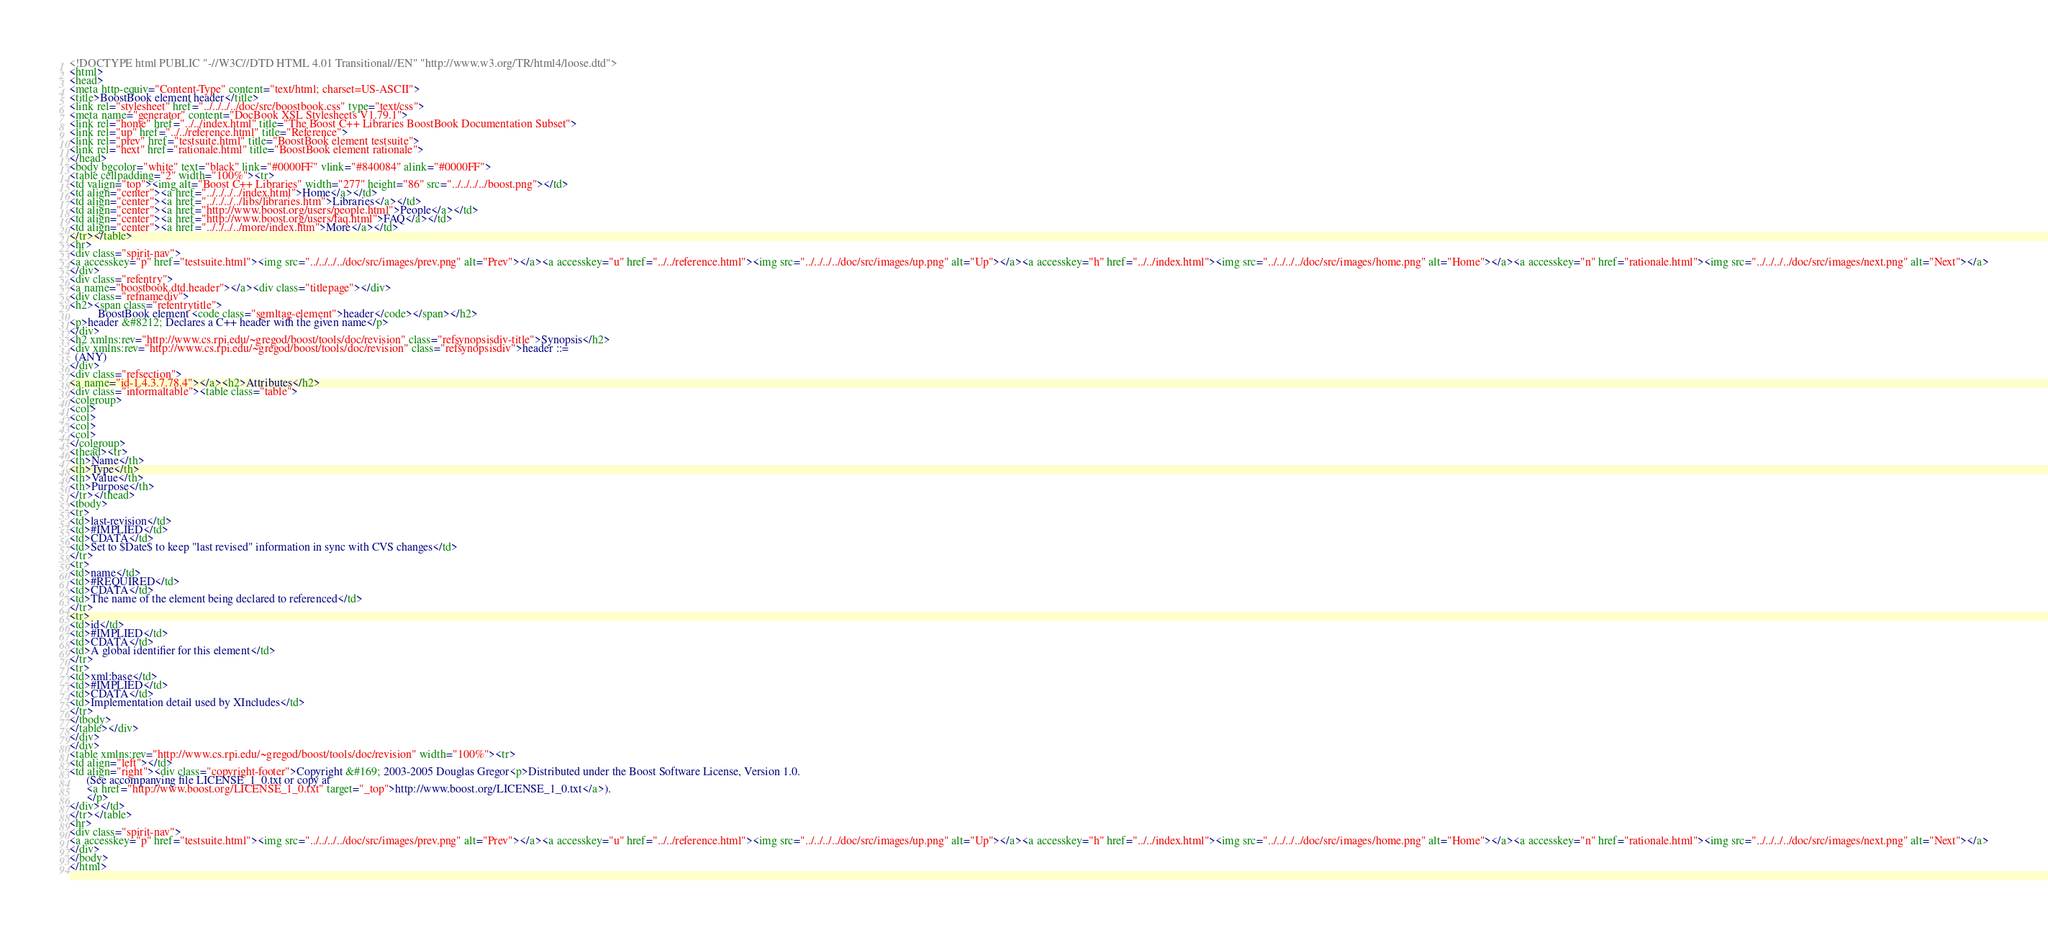<code> <loc_0><loc_0><loc_500><loc_500><_HTML_><!DOCTYPE html PUBLIC "-//W3C//DTD HTML 4.01 Transitional//EN" "http://www.w3.org/TR/html4/loose.dtd">
<html>
<head>
<meta http-equiv="Content-Type" content="text/html; charset=US-ASCII">
<title>BoostBook element header</title>
<link rel="stylesheet" href="../../../../doc/src/boostbook.css" type="text/css">
<meta name="generator" content="DocBook XSL Stylesheets V1.79.1">
<link rel="home" href="../../index.html" title="The Boost C++ Libraries BoostBook Documentation Subset">
<link rel="up" href="../../reference.html" title="Reference">
<link rel="prev" href="testsuite.html" title="BoostBook element testsuite">
<link rel="next" href="rationale.html" title="BoostBook element rationale">
</head>
<body bgcolor="white" text="black" link="#0000FF" vlink="#840084" alink="#0000FF">
<table cellpadding="2" width="100%"><tr>
<td valign="top"><img alt="Boost C++ Libraries" width="277" height="86" src="../../../../boost.png"></td>
<td align="center"><a href="../../../../index.html">Home</a></td>
<td align="center"><a href="../../../../libs/libraries.htm">Libraries</a></td>
<td align="center"><a href="http://www.boost.org/users/people.html">People</a></td>
<td align="center"><a href="http://www.boost.org/users/faq.html">FAQ</a></td>
<td align="center"><a href="../../../../more/index.htm">More</a></td>
</tr></table>
<hr>
<div class="spirit-nav">
<a accesskey="p" href="testsuite.html"><img src="../../../../doc/src/images/prev.png" alt="Prev"></a><a accesskey="u" href="../../reference.html"><img src="../../../../doc/src/images/up.png" alt="Up"></a><a accesskey="h" href="../../index.html"><img src="../../../../doc/src/images/home.png" alt="Home"></a><a accesskey="n" href="rationale.html"><img src="../../../../doc/src/images/next.png" alt="Next"></a>
</div>
<div class="refentry">
<a name="boostbook.dtd.header"></a><div class="titlepage"></div>
<div class="refnamediv">
<h2><span class="refentrytitle">
          BoostBook element <code class="sgmltag-element">header</code></span></h2>
<p>header &#8212; Declares a C++ header with the given name</p>
</div>
<h2 xmlns:rev="http://www.cs.rpi.edu/~gregod/boost/tools/doc/revision" class="refsynopsisdiv-title">Synopsis</h2>
<div xmlns:rev="http://www.cs.rpi.edu/~gregod/boost/tools/doc/revision" class="refsynopsisdiv">header ::= 
  (ANY)
</div>
<div class="refsection">
<a name="id-1.4.3.7.78.4"></a><h2>Attributes</h2>
<div class="informaltable"><table class="table">
<colgroup>
<col>
<col>
<col>
<col>
</colgroup>
<thead><tr>
<th>Name</th>
<th>Type</th>
<th>Value</th>
<th>Purpose</th>
</tr></thead>
<tbody>
<tr>
<td>last-revision</td>
<td>#IMPLIED</td>
<td>CDATA</td>
<td>Set to $Date$ to keep "last revised" information in sync with CVS changes</td>
</tr>
<tr>
<td>name</td>
<td>#REQUIRED</td>
<td>CDATA</td>
<td>The name of the element being declared to referenced</td>
</tr>
<tr>
<td>id</td>
<td>#IMPLIED</td>
<td>CDATA</td>
<td>A global identifier for this element</td>
</tr>
<tr>
<td>xml:base</td>
<td>#IMPLIED</td>
<td>CDATA</td>
<td>Implementation detail used by XIncludes</td>
</tr>
</tbody>
</table></div>
</div>
</div>
<table xmlns:rev="http://www.cs.rpi.edu/~gregod/boost/tools/doc/revision" width="100%"><tr>
<td align="left"></td>
<td align="right"><div class="copyright-footer">Copyright &#169; 2003-2005 Douglas Gregor<p>Distributed under the Boost Software License, Version 1.0.
      (See accompanying file LICENSE_1_0.txt or copy at
      <a href="http://www.boost.org/LICENSE_1_0.txt" target="_top">http://www.boost.org/LICENSE_1_0.txt</a>).
      </p>
</div></td>
</tr></table>
<hr>
<div class="spirit-nav">
<a accesskey="p" href="testsuite.html"><img src="../../../../doc/src/images/prev.png" alt="Prev"></a><a accesskey="u" href="../../reference.html"><img src="../../../../doc/src/images/up.png" alt="Up"></a><a accesskey="h" href="../../index.html"><img src="../../../../doc/src/images/home.png" alt="Home"></a><a accesskey="n" href="rationale.html"><img src="../../../../doc/src/images/next.png" alt="Next"></a>
</div>
</body>
</html>
</code> 